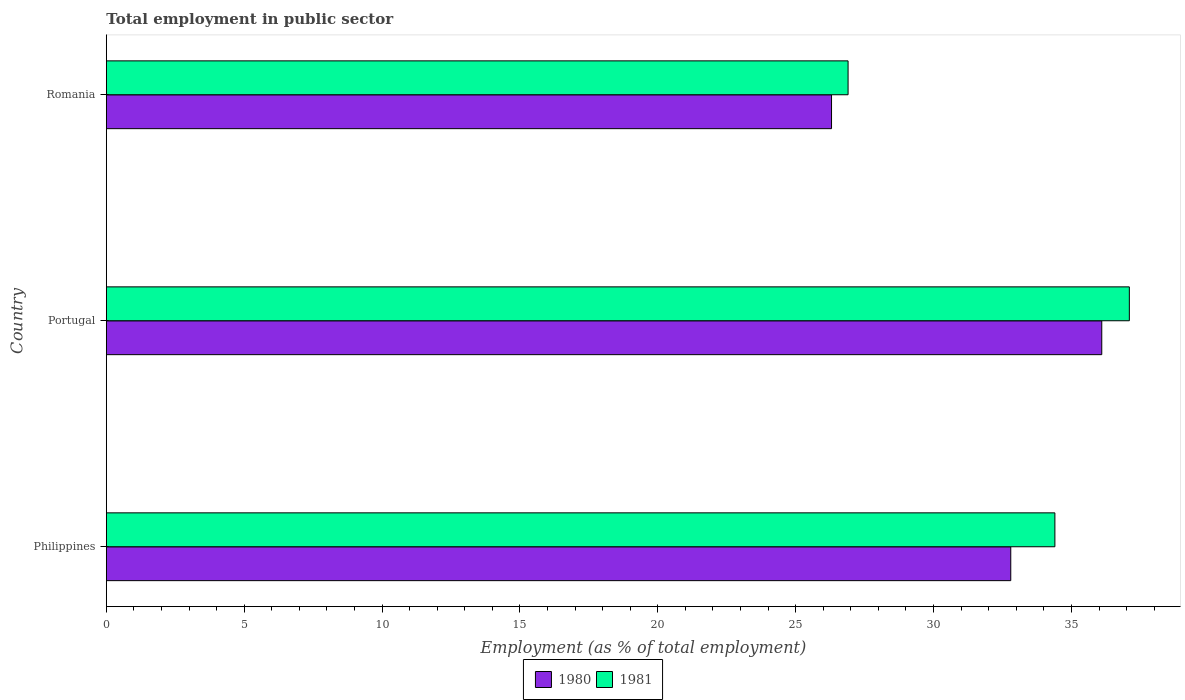How many different coloured bars are there?
Provide a short and direct response. 2. Are the number of bars per tick equal to the number of legend labels?
Give a very brief answer. Yes. Are the number of bars on each tick of the Y-axis equal?
Make the answer very short. Yes. What is the employment in public sector in 1980 in Romania?
Make the answer very short. 26.3. Across all countries, what is the maximum employment in public sector in 1981?
Ensure brevity in your answer.  37.1. Across all countries, what is the minimum employment in public sector in 1980?
Your answer should be compact. 26.3. In which country was the employment in public sector in 1980 maximum?
Keep it short and to the point. Portugal. In which country was the employment in public sector in 1980 minimum?
Keep it short and to the point. Romania. What is the total employment in public sector in 1981 in the graph?
Give a very brief answer. 98.4. What is the difference between the employment in public sector in 1980 in Philippines and that in Portugal?
Your response must be concise. -3.3. What is the difference between the employment in public sector in 1980 in Portugal and the employment in public sector in 1981 in Philippines?
Ensure brevity in your answer.  1.7. What is the average employment in public sector in 1981 per country?
Offer a very short reply. 32.8. What is the difference between the employment in public sector in 1981 and employment in public sector in 1980 in Philippines?
Your answer should be very brief. 1.6. What is the ratio of the employment in public sector in 1980 in Philippines to that in Romania?
Offer a very short reply. 1.25. Is the difference between the employment in public sector in 1981 in Philippines and Portugal greater than the difference between the employment in public sector in 1980 in Philippines and Portugal?
Offer a very short reply. Yes. What is the difference between the highest and the second highest employment in public sector in 1981?
Offer a terse response. 2.7. What is the difference between the highest and the lowest employment in public sector in 1980?
Offer a very short reply. 9.8. Are all the bars in the graph horizontal?
Make the answer very short. Yes. Are the values on the major ticks of X-axis written in scientific E-notation?
Provide a short and direct response. No. Does the graph contain grids?
Provide a succinct answer. No. Where does the legend appear in the graph?
Your answer should be very brief. Bottom center. How many legend labels are there?
Keep it short and to the point. 2. What is the title of the graph?
Keep it short and to the point. Total employment in public sector. Does "1970" appear as one of the legend labels in the graph?
Make the answer very short. No. What is the label or title of the X-axis?
Offer a very short reply. Employment (as % of total employment). What is the Employment (as % of total employment) in 1980 in Philippines?
Provide a short and direct response. 32.8. What is the Employment (as % of total employment) of 1981 in Philippines?
Keep it short and to the point. 34.4. What is the Employment (as % of total employment) in 1980 in Portugal?
Make the answer very short. 36.1. What is the Employment (as % of total employment) in 1981 in Portugal?
Ensure brevity in your answer.  37.1. What is the Employment (as % of total employment) in 1980 in Romania?
Give a very brief answer. 26.3. What is the Employment (as % of total employment) of 1981 in Romania?
Provide a short and direct response. 26.9. Across all countries, what is the maximum Employment (as % of total employment) in 1980?
Keep it short and to the point. 36.1. Across all countries, what is the maximum Employment (as % of total employment) of 1981?
Provide a succinct answer. 37.1. Across all countries, what is the minimum Employment (as % of total employment) in 1980?
Provide a short and direct response. 26.3. Across all countries, what is the minimum Employment (as % of total employment) in 1981?
Provide a succinct answer. 26.9. What is the total Employment (as % of total employment) of 1980 in the graph?
Provide a succinct answer. 95.2. What is the total Employment (as % of total employment) in 1981 in the graph?
Offer a terse response. 98.4. What is the difference between the Employment (as % of total employment) of 1980 in Philippines and that in Portugal?
Offer a terse response. -3.3. What is the difference between the Employment (as % of total employment) of 1981 in Philippines and that in Portugal?
Give a very brief answer. -2.7. What is the difference between the Employment (as % of total employment) in 1981 in Philippines and that in Romania?
Offer a terse response. 7.5. What is the average Employment (as % of total employment) in 1980 per country?
Offer a terse response. 31.73. What is the average Employment (as % of total employment) in 1981 per country?
Make the answer very short. 32.8. What is the difference between the Employment (as % of total employment) of 1980 and Employment (as % of total employment) of 1981 in Philippines?
Give a very brief answer. -1.6. What is the difference between the Employment (as % of total employment) in 1980 and Employment (as % of total employment) in 1981 in Portugal?
Offer a very short reply. -1. What is the ratio of the Employment (as % of total employment) in 1980 in Philippines to that in Portugal?
Keep it short and to the point. 0.91. What is the ratio of the Employment (as % of total employment) of 1981 in Philippines to that in Portugal?
Your answer should be very brief. 0.93. What is the ratio of the Employment (as % of total employment) in 1980 in Philippines to that in Romania?
Your answer should be very brief. 1.25. What is the ratio of the Employment (as % of total employment) in 1981 in Philippines to that in Romania?
Your response must be concise. 1.28. What is the ratio of the Employment (as % of total employment) of 1980 in Portugal to that in Romania?
Your answer should be very brief. 1.37. What is the ratio of the Employment (as % of total employment) in 1981 in Portugal to that in Romania?
Provide a short and direct response. 1.38. What is the difference between the highest and the second highest Employment (as % of total employment) of 1981?
Give a very brief answer. 2.7. What is the difference between the highest and the lowest Employment (as % of total employment) of 1981?
Your answer should be very brief. 10.2. 